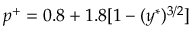<formula> <loc_0><loc_0><loc_500><loc_500>p ^ { + } = 0 . 8 + 1 . 8 [ 1 - ( y ^ { \ast } ) ^ { 3 / 2 } ]</formula> 